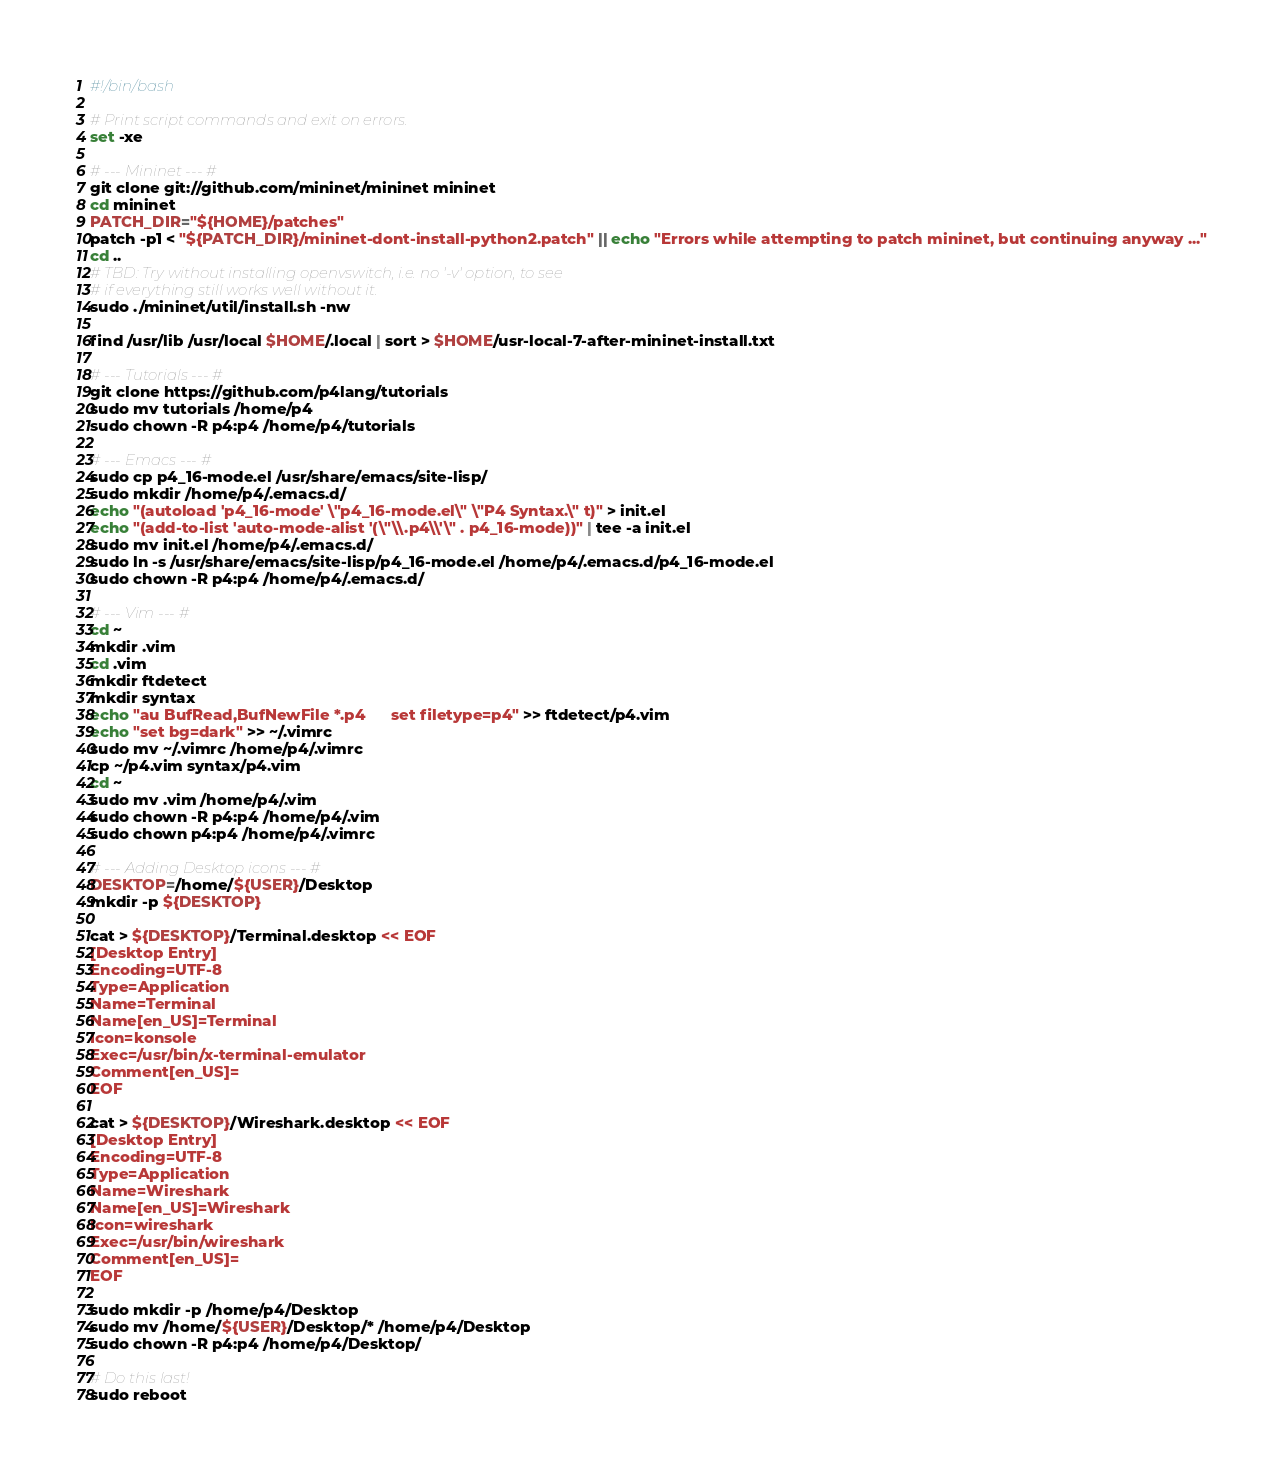<code> <loc_0><loc_0><loc_500><loc_500><_Bash_>#!/bin/bash

# Print script commands and exit on errors.
set -xe

# --- Mininet --- #
git clone git://github.com/mininet/mininet mininet
cd mininet
PATCH_DIR="${HOME}/patches"
patch -p1 < "${PATCH_DIR}/mininet-dont-install-python2.patch" || echo "Errors while attempting to patch mininet, but continuing anyway ..."
cd ..
# TBD: Try without installing openvswitch, i.e. no '-v' option, to see
# if everything still works well without it.
sudo ./mininet/util/install.sh -nw

find /usr/lib /usr/local $HOME/.local | sort > $HOME/usr-local-7-after-mininet-install.txt

# --- Tutorials --- #
git clone https://github.com/p4lang/tutorials
sudo mv tutorials /home/p4
sudo chown -R p4:p4 /home/p4/tutorials

# --- Emacs --- #
sudo cp p4_16-mode.el /usr/share/emacs/site-lisp/
sudo mkdir /home/p4/.emacs.d/
echo "(autoload 'p4_16-mode' \"p4_16-mode.el\" \"P4 Syntax.\" t)" > init.el
echo "(add-to-list 'auto-mode-alist '(\"\\.p4\\'\" . p4_16-mode))" | tee -a init.el
sudo mv init.el /home/p4/.emacs.d/
sudo ln -s /usr/share/emacs/site-lisp/p4_16-mode.el /home/p4/.emacs.d/p4_16-mode.el
sudo chown -R p4:p4 /home/p4/.emacs.d/

# --- Vim --- #
cd ~
mkdir .vim
cd .vim
mkdir ftdetect
mkdir syntax
echo "au BufRead,BufNewFile *.p4      set filetype=p4" >> ftdetect/p4.vim
echo "set bg=dark" >> ~/.vimrc
sudo mv ~/.vimrc /home/p4/.vimrc
cp ~/p4.vim syntax/p4.vim
cd ~
sudo mv .vim /home/p4/.vim
sudo chown -R p4:p4 /home/p4/.vim
sudo chown p4:p4 /home/p4/.vimrc

# --- Adding Desktop icons --- #
DESKTOP=/home/${USER}/Desktop
mkdir -p ${DESKTOP}

cat > ${DESKTOP}/Terminal.desktop << EOF
[Desktop Entry]
Encoding=UTF-8
Type=Application
Name=Terminal
Name[en_US]=Terminal
Icon=konsole
Exec=/usr/bin/x-terminal-emulator
Comment[en_US]=
EOF

cat > ${DESKTOP}/Wireshark.desktop << EOF
[Desktop Entry]
Encoding=UTF-8
Type=Application
Name=Wireshark
Name[en_US]=Wireshark
Icon=wireshark
Exec=/usr/bin/wireshark
Comment[en_US]=
EOF

sudo mkdir -p /home/p4/Desktop
sudo mv /home/${USER}/Desktop/* /home/p4/Desktop
sudo chown -R p4:p4 /home/p4/Desktop/

# Do this last!
sudo reboot
</code> 